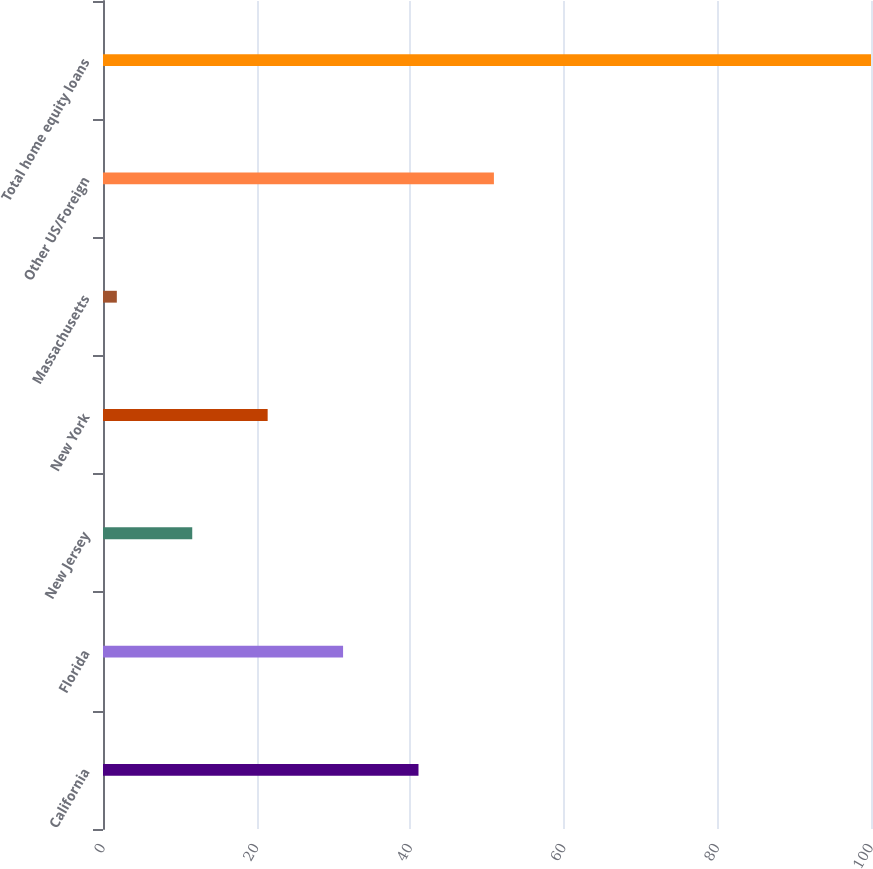Convert chart to OTSL. <chart><loc_0><loc_0><loc_500><loc_500><bar_chart><fcel>California<fcel>Florida<fcel>New Jersey<fcel>New York<fcel>Massachusetts<fcel>Other US/Foreign<fcel>Total home equity loans<nl><fcel>41.08<fcel>31.26<fcel>11.62<fcel>21.44<fcel>1.8<fcel>50.9<fcel>100<nl></chart> 